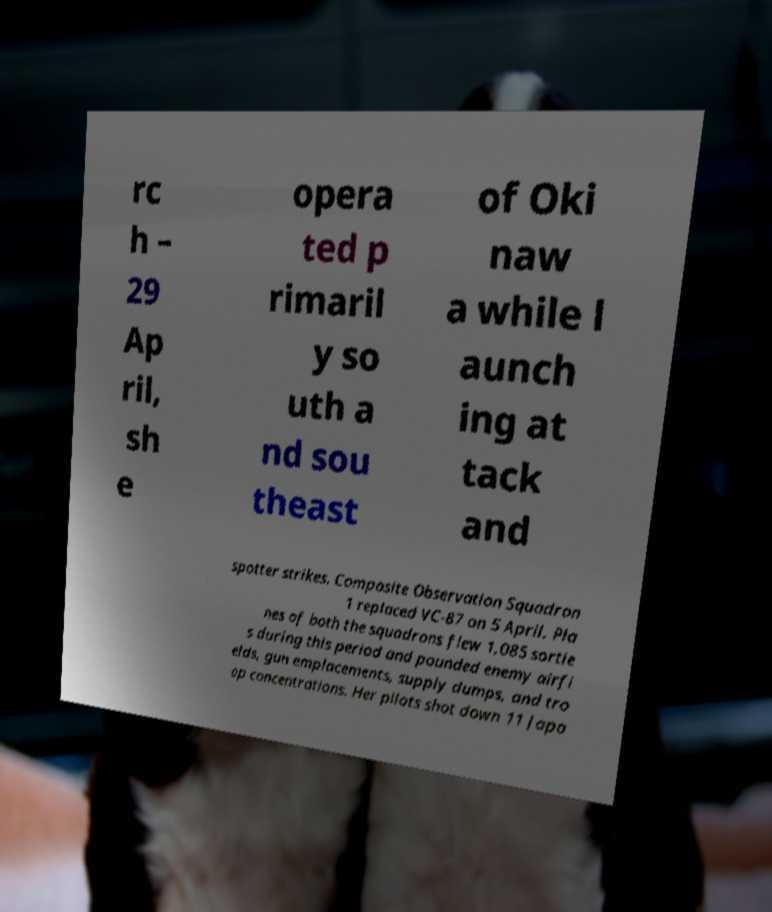Could you assist in decoding the text presented in this image and type it out clearly? rc h – 29 Ap ril, sh e opera ted p rimaril y so uth a nd sou theast of Oki naw a while l aunch ing at tack and spotter strikes. Composite Observation Squadron 1 replaced VC-87 on 5 April. Pla nes of both the squadrons flew 1,085 sortie s during this period and pounded enemy airfi elds, gun emplacements, supply dumps, and tro op concentrations. Her pilots shot down 11 Japa 